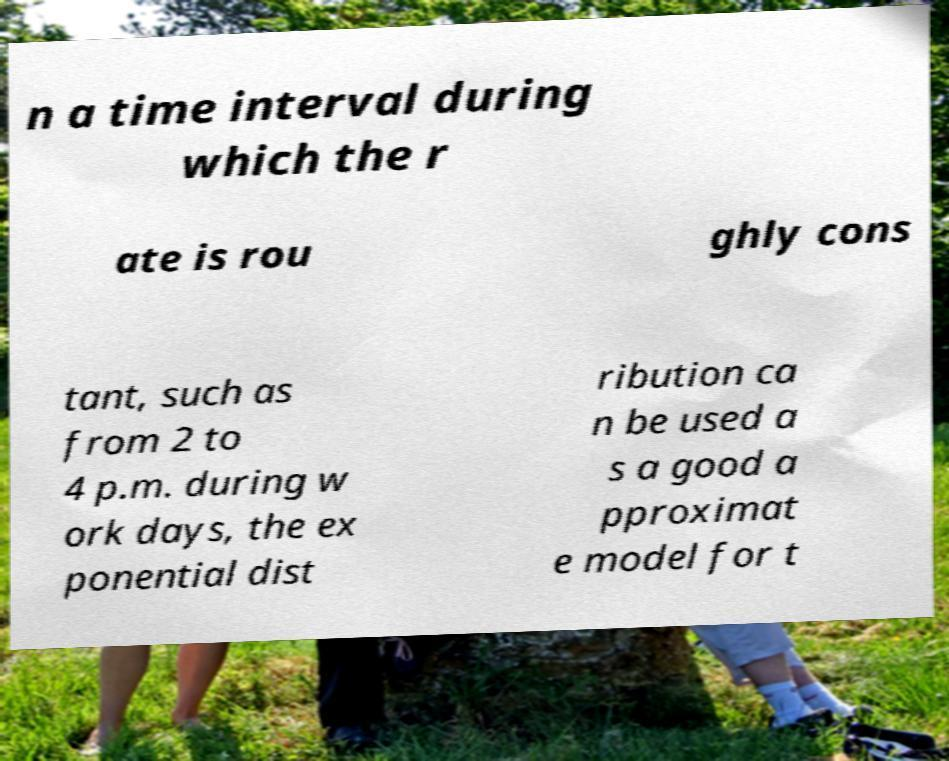Can you read and provide the text displayed in the image?This photo seems to have some interesting text. Can you extract and type it out for me? n a time interval during which the r ate is rou ghly cons tant, such as from 2 to 4 p.m. during w ork days, the ex ponential dist ribution ca n be used a s a good a pproximat e model for t 